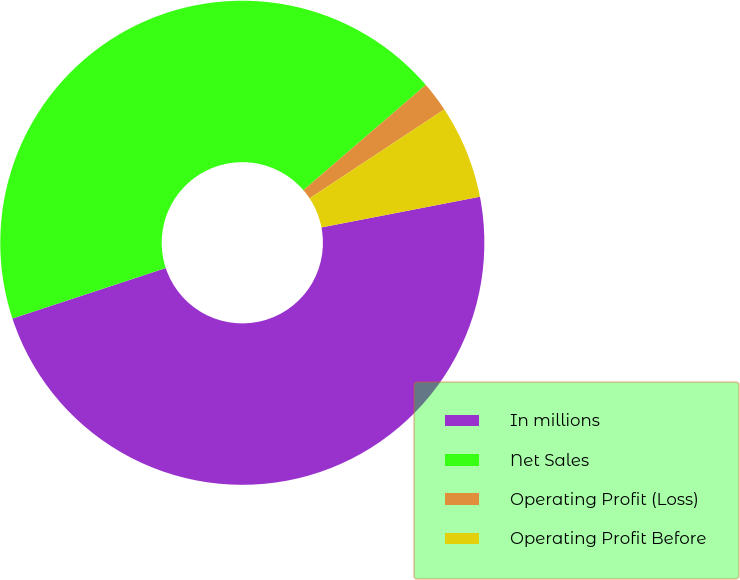Convert chart to OTSL. <chart><loc_0><loc_0><loc_500><loc_500><pie_chart><fcel>In millions<fcel>Net Sales<fcel>Operating Profit (Loss)<fcel>Operating Profit Before<nl><fcel>47.98%<fcel>43.76%<fcel>2.02%<fcel>6.24%<nl></chart> 